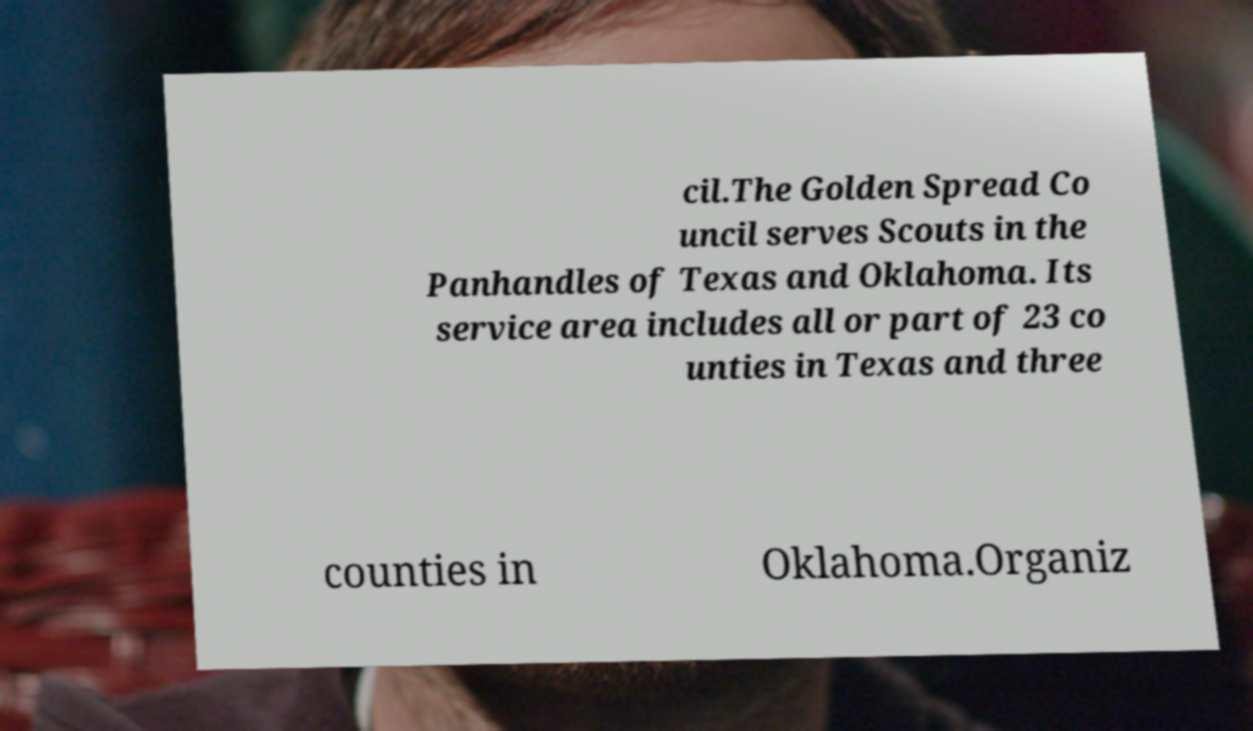What messages or text are displayed in this image? I need them in a readable, typed format. cil.The Golden Spread Co uncil serves Scouts in the Panhandles of Texas and Oklahoma. Its service area includes all or part of 23 co unties in Texas and three counties in Oklahoma.Organiz 